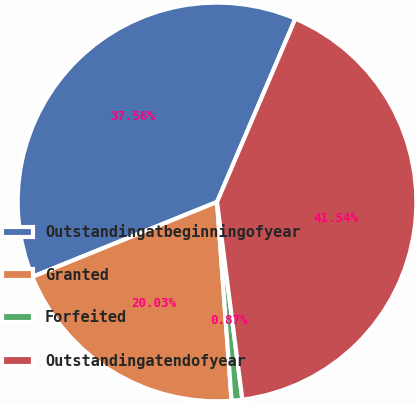Convert chart to OTSL. <chart><loc_0><loc_0><loc_500><loc_500><pie_chart><fcel>Outstandingatbeginningofyear<fcel>Granted<fcel>Forfeited<fcel>Outstandingatendofyear<nl><fcel>37.56%<fcel>20.03%<fcel>0.87%<fcel>41.54%<nl></chart> 